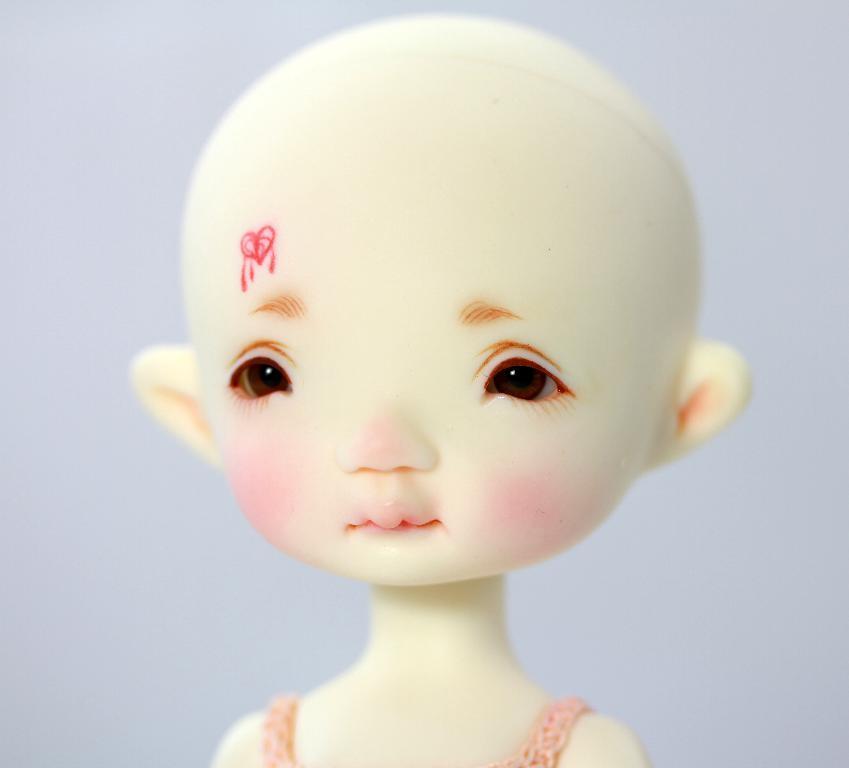Could you give a brief overview of what you see in this image? In this picture we can see doll, which looks like a girl. On the back we can see white color wall. This doll is wearing pink color dress. 